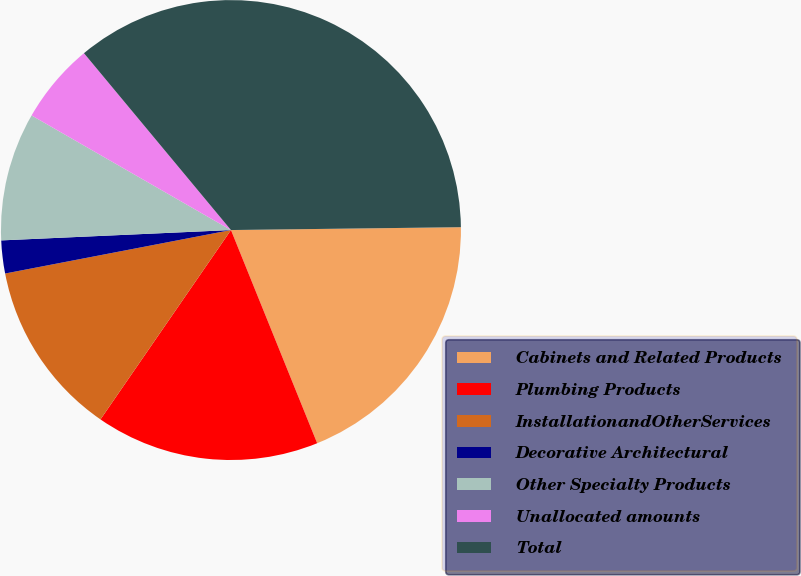Convert chart to OTSL. <chart><loc_0><loc_0><loc_500><loc_500><pie_chart><fcel>Cabinets and Related Products<fcel>Plumbing Products<fcel>InstallationandOtherServices<fcel>Decorative Architectural<fcel>Other Specialty Products<fcel>Unallocated amounts<fcel>Total<nl><fcel>19.08%<fcel>15.72%<fcel>12.37%<fcel>2.31%<fcel>9.02%<fcel>5.66%<fcel>35.84%<nl></chart> 